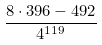<formula> <loc_0><loc_0><loc_500><loc_500>\frac { 8 \cdot 3 9 6 - 4 9 2 } { 4 ^ { 1 1 9 } }</formula> 